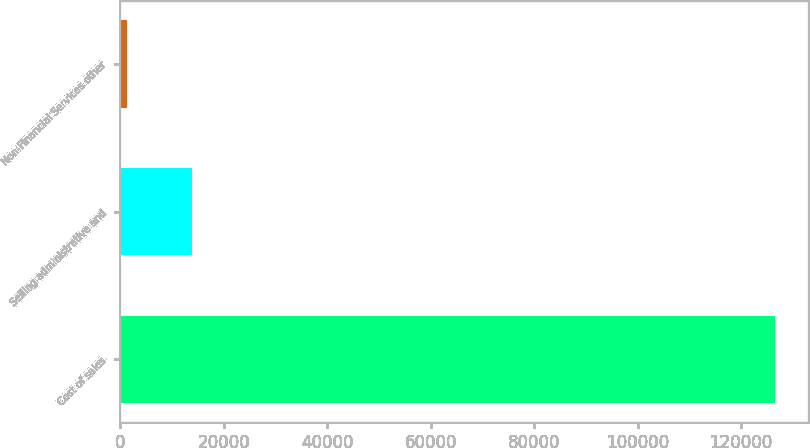Convert chart. <chart><loc_0><loc_0><loc_500><loc_500><bar_chart><fcel>Cost of sales<fcel>Selling administrative and<fcel>Non-Financial Services other<nl><fcel>126584<fcel>13878.8<fcel>1356<nl></chart> 